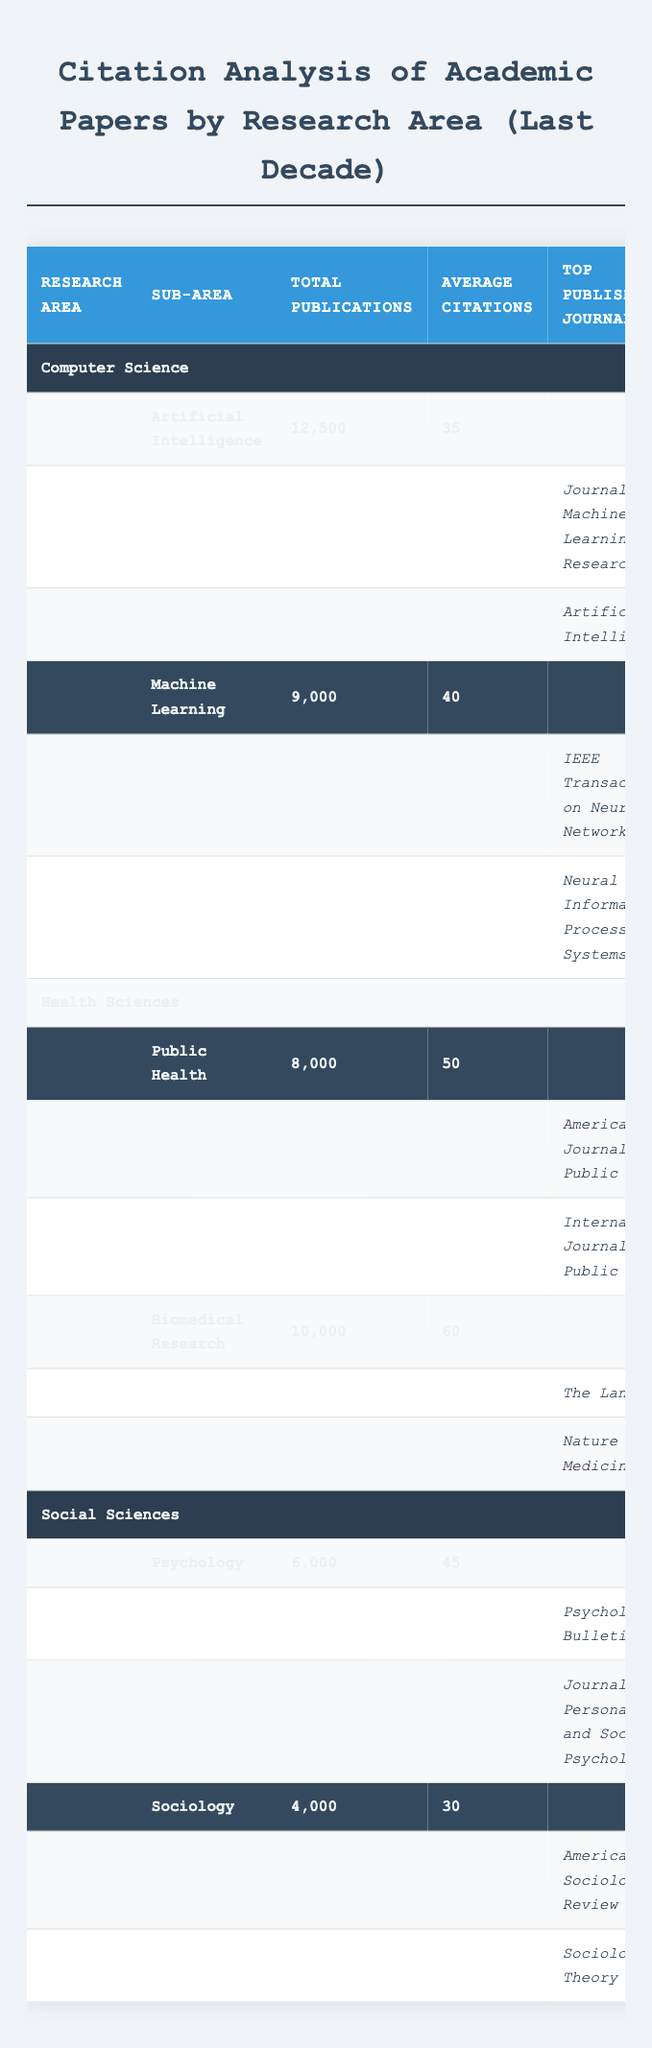What is the total number of publications in the Computer Science area? The total number of publications in the Computer Science area consists of the publications from its sub-areas: Artificial Intelligence with 12,500 and Machine Learning with 9,000. Therefore, the total is 12,500 + 9,000 = 21,500.
Answer: 21,500 Which research area has the highest average citations? The average citations for each research area are: Computer Science (37.5), Health Sciences (55), and Social Sciences (37.5). Health Sciences has the highest average citations.
Answer: Health Sciences How many publications are in the Biomedical Research sub-area? The table shows that the Biomedical Research sub-area has 10,000 publications listed directly under it.
Answer: 10,000 Is it true that the American Journal of Public Health has more citations than The Lancet? The citations for the American Journal of Public Health are 20,000, while The Lancet has 30,000 citations. Since 20,000 is less than 30,000, this statement is false.
Answer: No What is the combined average number of citations for the sub-areas of Social Sciences? To find the combined average for Social Sciences, we first find the total average citations: Psychology has 45, and Sociology has 30. Thus, (45 + 30) / 2 = 37.5, so the combined average is 37.5.
Answer: 37.5 Which sub-area has the highest total publications in Health Sciences? Among the sub-areas in Health Sciences, Public Health has 8,000 and Biomedical Research has 10,000 publications. Therefore, Biomedical Research has the highest total publications.
Answer: Biomedical Research How many total citations do the top journals in Artificial Intelligence have? The top journals in Artificial Intelligence are the Journal of Machine Learning Research with 12,000 citations and Artificial Intelligence with 8,000 citations. Adding these yields 12,000 + 8,000 = 20,000 citations total.
Answer: 20,000 Are there more publications in Psychology than in Sociology? Psychology has 6,000 publications while Sociology has 4,000. Since 6,000 > 4,000, there are indeed more publications in Psychology.
Answer: Yes What is the sum of citations from top journals in the Health Sciences area? The top journals in Health Sciences are the American Journal of Public Health with 20,000 citations and International Journal of Public Health with 12,000 citations. The sum of citations is 20,000 + 12,000 = 32,000.
Answer: 32,000 